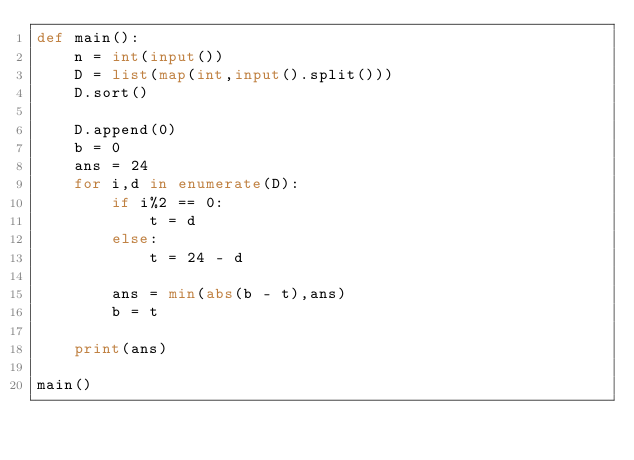<code> <loc_0><loc_0><loc_500><loc_500><_Python_>def main():
    n = int(input())
    D = list(map(int,input().split()))
    D.sort()

    D.append(0)
    b = 0
    ans = 24
    for i,d in enumerate(D):
        if i%2 == 0:
            t = d
        else:
            t = 24 - d

        ans = min(abs(b - t),ans)
        b = t

    print(ans)

main()</code> 